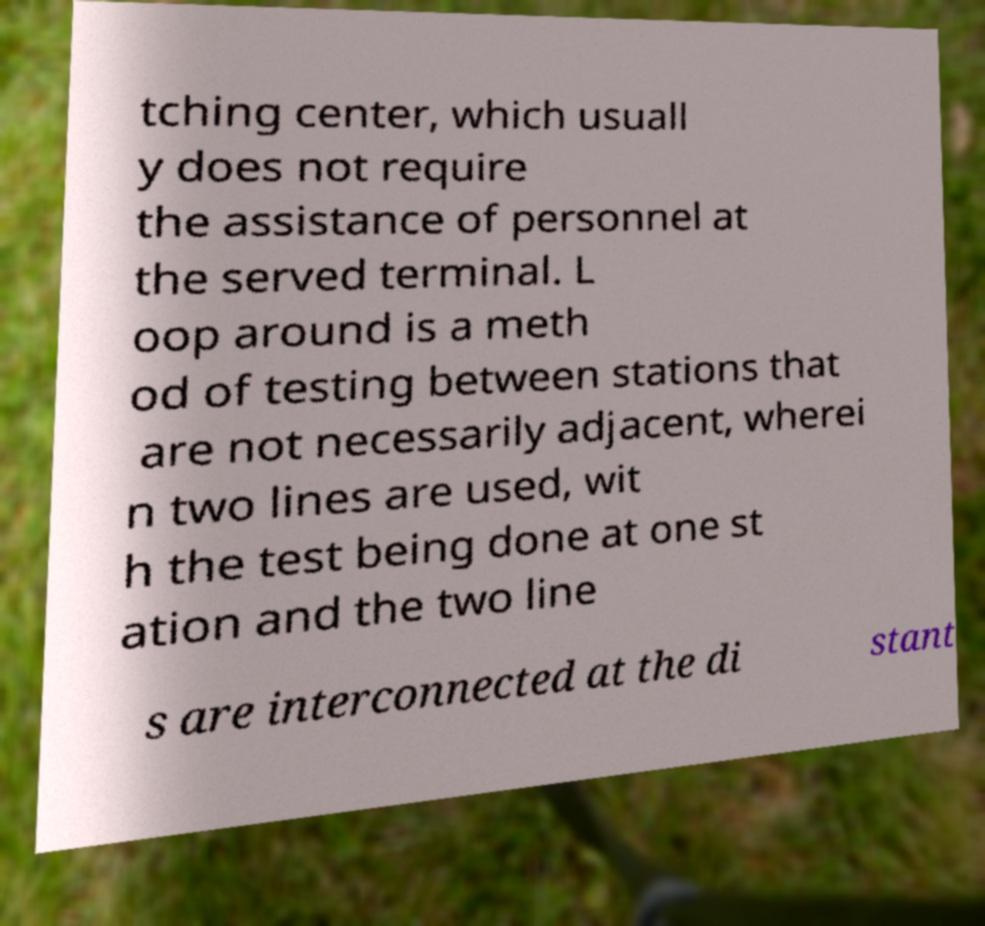Could you extract and type out the text from this image? tching center, which usuall y does not require the assistance of personnel at the served terminal. L oop around is a meth od of testing between stations that are not necessarily adjacent, wherei n two lines are used, wit h the test being done at one st ation and the two line s are interconnected at the di stant 